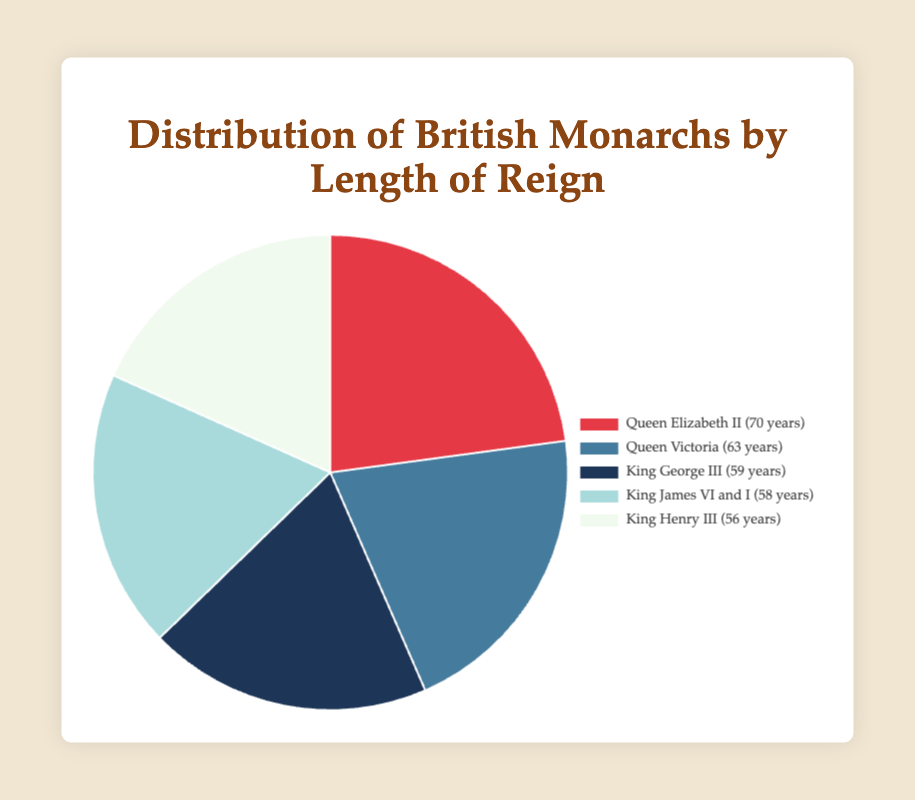What percentage of the total do Queen Victoria and King George III together represent? Queen Victoria represents 23.18% and King George III represents 21.72%. Summing these percentages, we get 23.18 + 21.72 = 44.90%.
Answer: 44.90% Who reigned longer, King James VI and I or King Henry III? King James VI and I reigned for 58 years while King Henry III reigned for 56 years. Therefore, King James VI and I reigned longer.
Answer: King James VI and I Which monarch has the largest segment in the pie chart? The largest segment in the pie chart represents Queen Elizabeth II, who reigned for 70 years.
Answer: Queen Elizabeth II Is the percentage of King James VI and I's reign greater than or less than Queen Victoria's reign? King James VI and I's reign represents 21.34%, while Queen Victoria's reign represents 23.18%. Therefore, King James VI and I's percentage is less than Queen Victoria's.
Answer: Less than What is the average percentage of all the monarchs' reigns? The percentages are 25.75, 23.18, 21.72, 21.34, and 20.61. Summing these up gives 112.60%. Dividing this sum by 5 (number of monarchs) gives the average: 112.60 / 5 = 22.52%.
Answer: 22.52% How many years did the two shortest-reigning monarchs rule together? The two shortest reigning monarchs are King James VI and I (58 years) and King Henry III (56 years). Summing these gives 58 + 56 = 114 years.
Answer: 114 years Visually, which segment color represents King George III's reign? King George III's reign is represented by a dark blue color segment in the pie chart.
Answer: Dark blue Which two monarchs have the most similar lengths of reign? King George III reigned for 59 years and King James VI and I reigned for 58 years, making them the most similar in length of reign.
Answer: King George III and King James VI and I Who reigned for a shorter time, Queen Victoria or King George III? Queen Victoria reigned for 63 years while King George III reigned for 59 years. Therefore, King George III reigned for a shorter time.
Answer: King George III Which monarch's segment is shown in light blue? The segment shown in light blue represents King James VI and I, who reigned for 58 years.
Answer: King James VI and I 